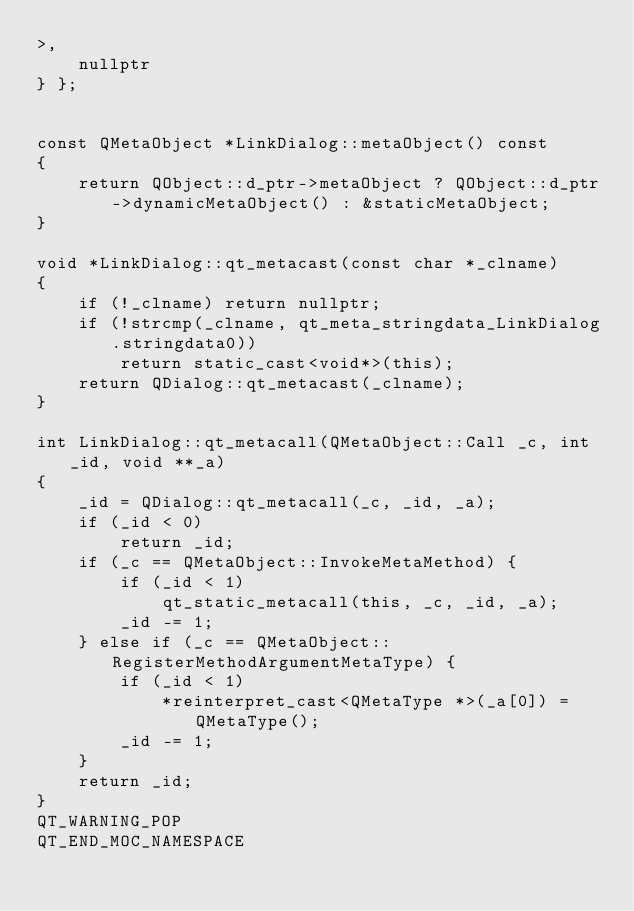Convert code to text. <code><loc_0><loc_0><loc_500><loc_500><_C++_>>,
    nullptr
} };


const QMetaObject *LinkDialog::metaObject() const
{
    return QObject::d_ptr->metaObject ? QObject::d_ptr->dynamicMetaObject() : &staticMetaObject;
}

void *LinkDialog::qt_metacast(const char *_clname)
{
    if (!_clname) return nullptr;
    if (!strcmp(_clname, qt_meta_stringdata_LinkDialog.stringdata0))
        return static_cast<void*>(this);
    return QDialog::qt_metacast(_clname);
}

int LinkDialog::qt_metacall(QMetaObject::Call _c, int _id, void **_a)
{
    _id = QDialog::qt_metacall(_c, _id, _a);
    if (_id < 0)
        return _id;
    if (_c == QMetaObject::InvokeMetaMethod) {
        if (_id < 1)
            qt_static_metacall(this, _c, _id, _a);
        _id -= 1;
    } else if (_c == QMetaObject::RegisterMethodArgumentMetaType) {
        if (_id < 1)
            *reinterpret_cast<QMetaType *>(_a[0]) = QMetaType();
        _id -= 1;
    }
    return _id;
}
QT_WARNING_POP
QT_END_MOC_NAMESPACE
</code> 